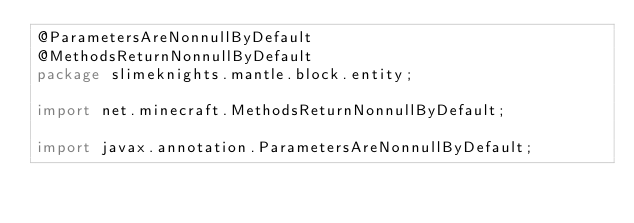<code> <loc_0><loc_0><loc_500><loc_500><_Java_>@ParametersAreNonnullByDefault
@MethodsReturnNonnullByDefault
package slimeknights.mantle.block.entity;

import net.minecraft.MethodsReturnNonnullByDefault;

import javax.annotation.ParametersAreNonnullByDefault;
</code> 